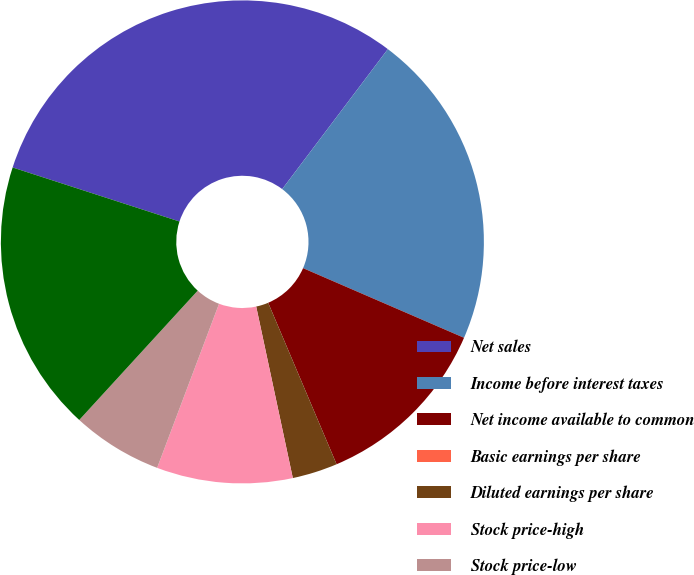Convert chart. <chart><loc_0><loc_0><loc_500><loc_500><pie_chart><fcel>Net sales<fcel>Income before interest taxes<fcel>Net income available to common<fcel>Basic earnings per share<fcel>Diluted earnings per share<fcel>Stock price-high<fcel>Stock price-low<fcel>Net income<nl><fcel>30.3%<fcel>21.21%<fcel>12.12%<fcel>0.0%<fcel>3.03%<fcel>9.09%<fcel>6.06%<fcel>18.18%<nl></chart> 